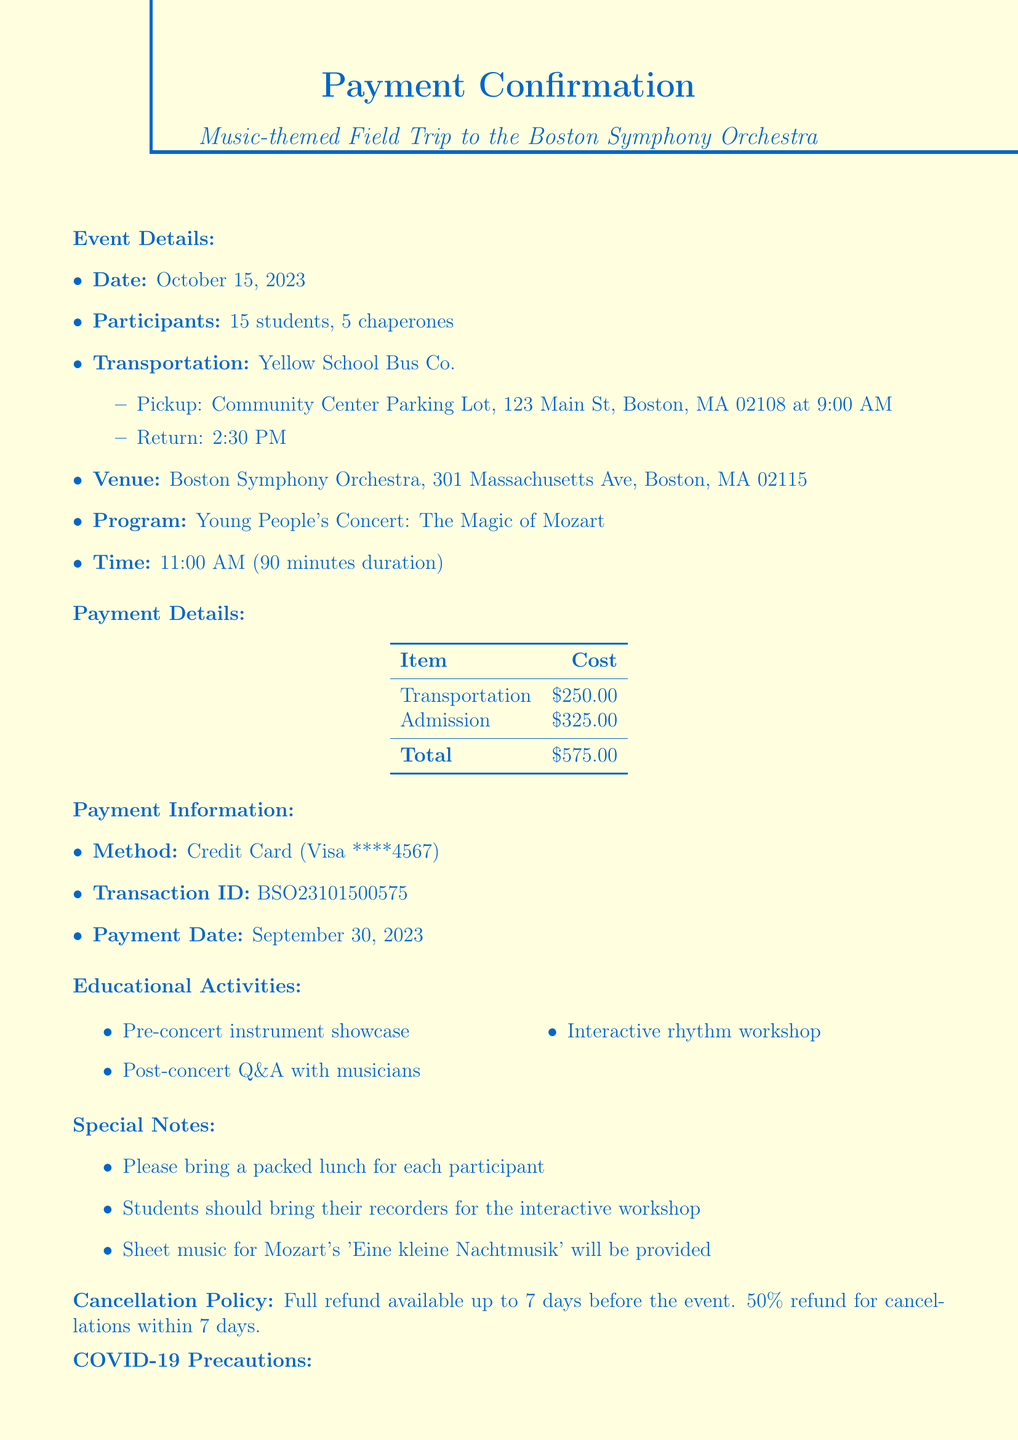what is the date of the field trip? The date of the field trip is mentioned in the document as October 15, 2023.
Answer: October 15, 2023 who is the contact person for the event? The contact person for the event is specified in the document as Emma Thompson.
Answer: Emma Thompson how many students are participating? The document states that there are 15 students participating in the field trip.
Answer: 15 what is the total cost for transportation? The total transportation cost is clearly indicated in the document as $250.00.
Answer: $250.00 what activities are included in the educational program? The document lists three educational activities associated with the trip. These include a pre-concert instrument showcase, a post-concert Q&A with musicians, and an interactive rhythm workshop.
Answer: Pre-concert instrument showcase, Post-concert Q&A with musicians, Interactive rhythm workshop what is the cancellation policy? The cancellation policy is explained in the document, stating the terms for a refund depending on the timing of the cancellation.
Answer: Full refund available up to 7 days before the event. 50% refund for cancellations within 7 days what type of payment method was used? The payment method used for the trip is specified in the payment details section of the document.
Answer: Credit Card where is the venue for the concert? The document provides the address of the venue where the concert will be held.
Answer: 301 Massachusetts Ave, Boston, MA 02115 how many chaperones will be attending? The document indicates that there will be 5 chaperones accompanying the students on the field trip.
Answer: 5 